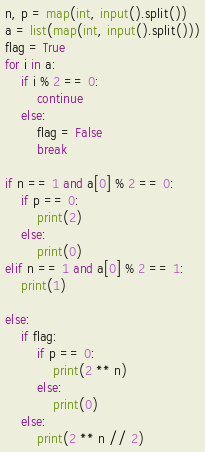<code> <loc_0><loc_0><loc_500><loc_500><_Python_>n, p = map(int, input().split())
a = list(map(int, input().split()))
flag = True
for i in a:
    if i % 2 == 0:
        continue
    else:
        flag = False
        break

if n == 1 and a[0] % 2 == 0:
    if p == 0:
        print(2)
    else:
        print(0)
elif n == 1 and a[0] % 2 == 1:
    print(1)

else:
    if flag:
        if p == 0:
            print(2 ** n)
        else:
            print(0)
    else:
        print(2 ** n // 2)
</code> 